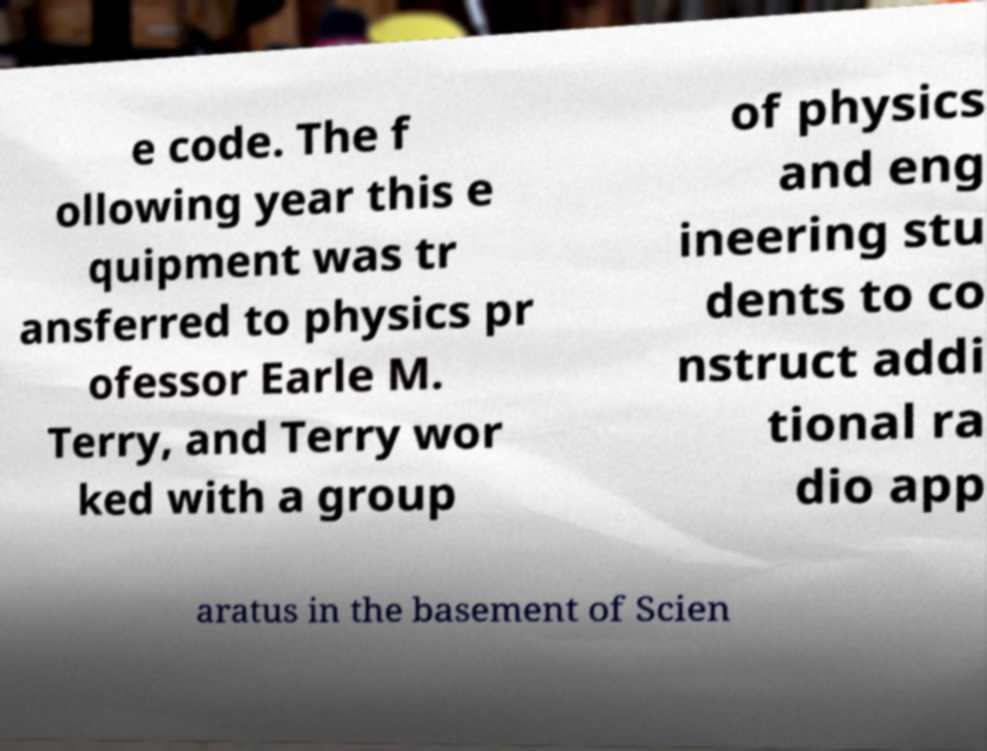Could you extract and type out the text from this image? e code. The f ollowing year this e quipment was tr ansferred to physics pr ofessor Earle M. Terry, and Terry wor ked with a group of physics and eng ineering stu dents to co nstruct addi tional ra dio app aratus in the basement of Scien 